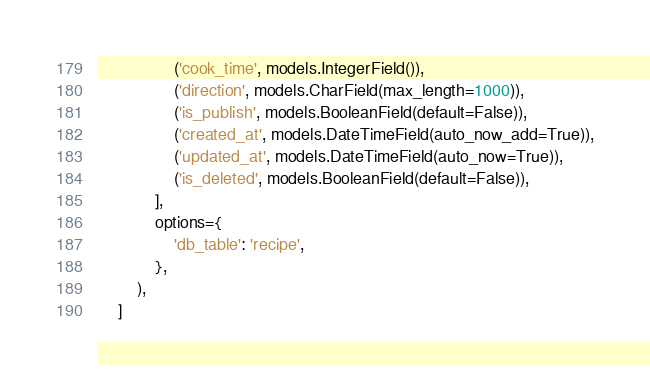<code> <loc_0><loc_0><loc_500><loc_500><_Python_>                ('cook_time', models.IntegerField()),
                ('direction', models.CharField(max_length=1000)),
                ('is_publish', models.BooleanField(default=False)),
                ('created_at', models.DateTimeField(auto_now_add=True)),
                ('updated_at', models.DateTimeField(auto_now=True)),
                ('is_deleted', models.BooleanField(default=False)),
            ],
            options={
                'db_table': 'recipe',
            },
        ),
    ]
</code> 